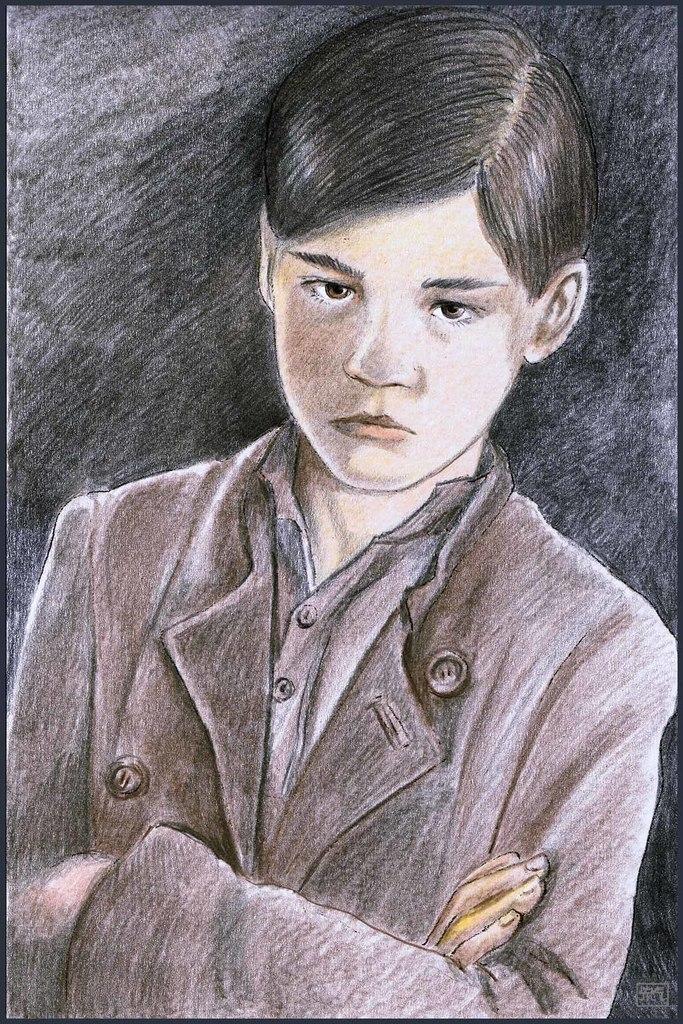Could you give a brief overview of what you see in this image? In this image we can see a drawing of a boy wearing a jacket.   